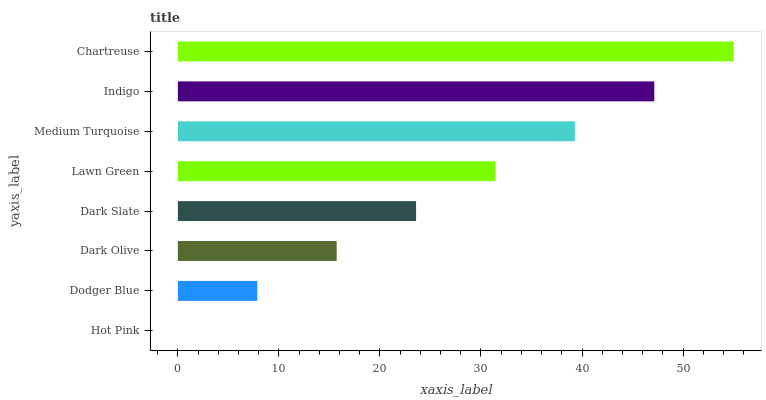Is Hot Pink the minimum?
Answer yes or no. Yes. Is Chartreuse the maximum?
Answer yes or no. Yes. Is Dodger Blue the minimum?
Answer yes or no. No. Is Dodger Blue the maximum?
Answer yes or no. No. Is Dodger Blue greater than Hot Pink?
Answer yes or no. Yes. Is Hot Pink less than Dodger Blue?
Answer yes or no. Yes. Is Hot Pink greater than Dodger Blue?
Answer yes or no. No. Is Dodger Blue less than Hot Pink?
Answer yes or no. No. Is Lawn Green the high median?
Answer yes or no. Yes. Is Dark Slate the low median?
Answer yes or no. Yes. Is Medium Turquoise the high median?
Answer yes or no. No. Is Dodger Blue the low median?
Answer yes or no. No. 